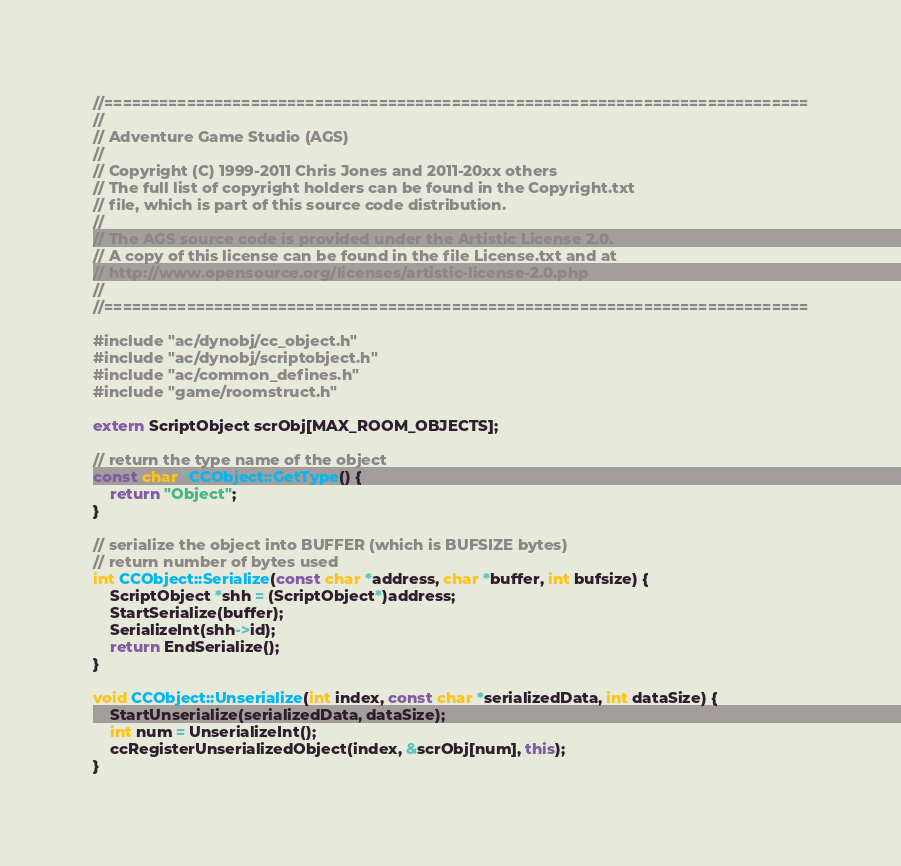Convert code to text. <code><loc_0><loc_0><loc_500><loc_500><_C++_>//=============================================================================
//
// Adventure Game Studio (AGS)
//
// Copyright (C) 1999-2011 Chris Jones and 2011-20xx others
// The full list of copyright holders can be found in the Copyright.txt
// file, which is part of this source code distribution.
//
// The AGS source code is provided under the Artistic License 2.0.
// A copy of this license can be found in the file License.txt and at
// http://www.opensource.org/licenses/artistic-license-2.0.php
//
//=============================================================================

#include "ac/dynobj/cc_object.h"
#include "ac/dynobj/scriptobject.h"
#include "ac/common_defines.h"
#include "game/roomstruct.h"

extern ScriptObject scrObj[MAX_ROOM_OBJECTS];

// return the type name of the object
const char *CCObject::GetType() {
    return "Object";
}

// serialize the object into BUFFER (which is BUFSIZE bytes)
// return number of bytes used
int CCObject::Serialize(const char *address, char *buffer, int bufsize) {
    ScriptObject *shh = (ScriptObject*)address;
    StartSerialize(buffer);
    SerializeInt(shh->id);
    return EndSerialize();
}

void CCObject::Unserialize(int index, const char *serializedData, int dataSize) {
    StartUnserialize(serializedData, dataSize);
    int num = UnserializeInt();
    ccRegisterUnserializedObject(index, &scrObj[num], this);
}
</code> 